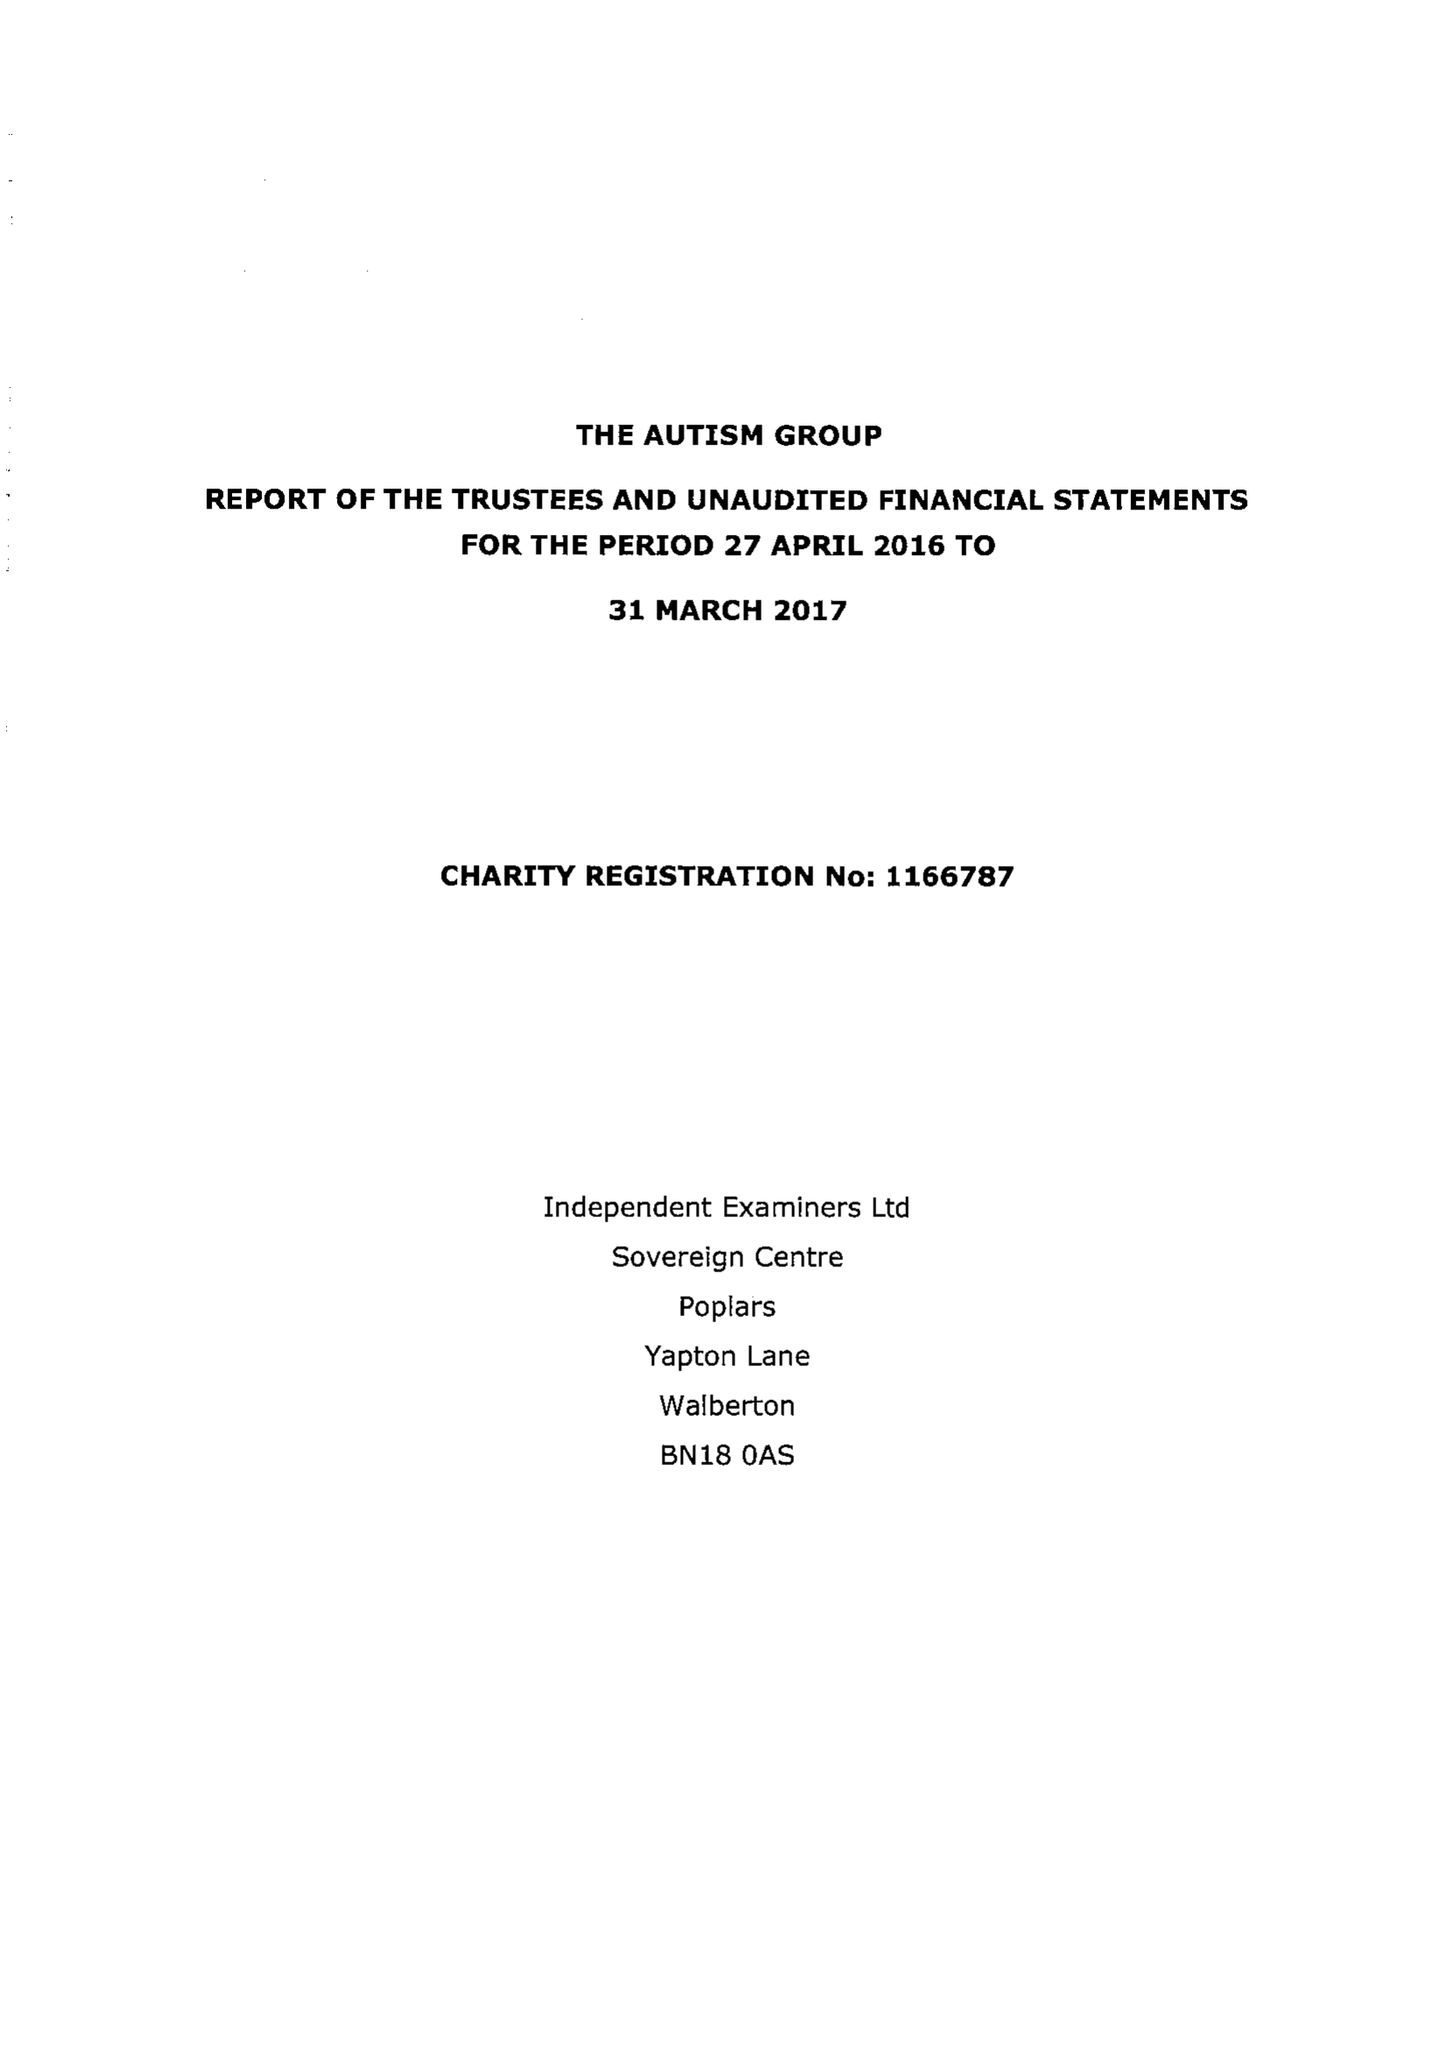What is the value for the income_annually_in_british_pounds?
Answer the question using a single word or phrase. 33639.00 